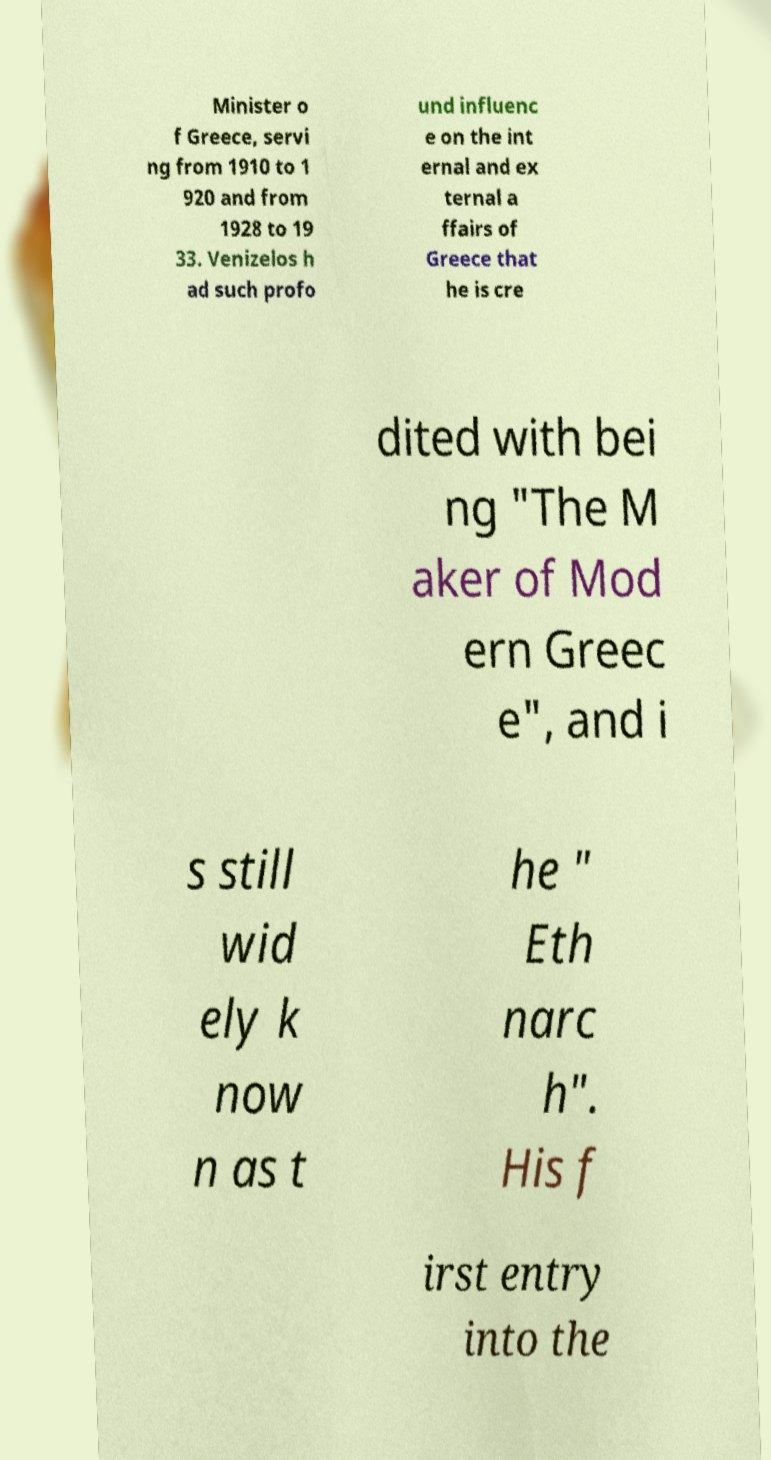There's text embedded in this image that I need extracted. Can you transcribe it verbatim? Minister o f Greece, servi ng from 1910 to 1 920 and from 1928 to 19 33. Venizelos h ad such profo und influenc e on the int ernal and ex ternal a ffairs of Greece that he is cre dited with bei ng "The M aker of Mod ern Greec e", and i s still wid ely k now n as t he " Eth narc h". His f irst entry into the 